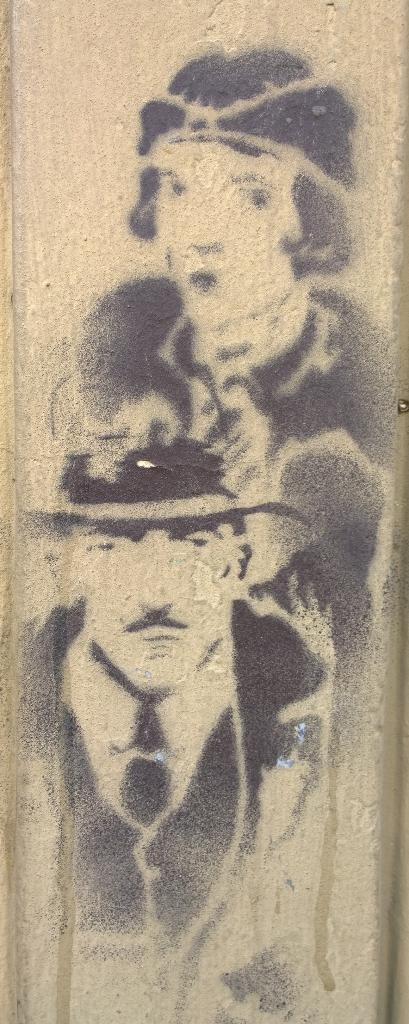What is the main subject of the image? The main subject of the image is a painting. What is depicted in the painting? The painting depicts a man and a woman. What type of steel is used to create the frame of the painting in the image? There is no information about the frame of the painting or the type of steel used in the image. 